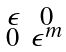Convert formula to latex. <formula><loc_0><loc_0><loc_500><loc_500>\begin{smallmatrix} \epsilon & 0 \\ 0 & \epsilon ^ { m } \end{smallmatrix}</formula> 